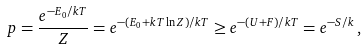<formula> <loc_0><loc_0><loc_500><loc_500>p = \frac { e ^ { - E _ { 0 } / k T } } { Z } = e ^ { - ( E _ { 0 } + k T \ln Z ) / k T } \geq e ^ { - ( U + F ) / k T } = e ^ { - S / k } \, ,</formula> 